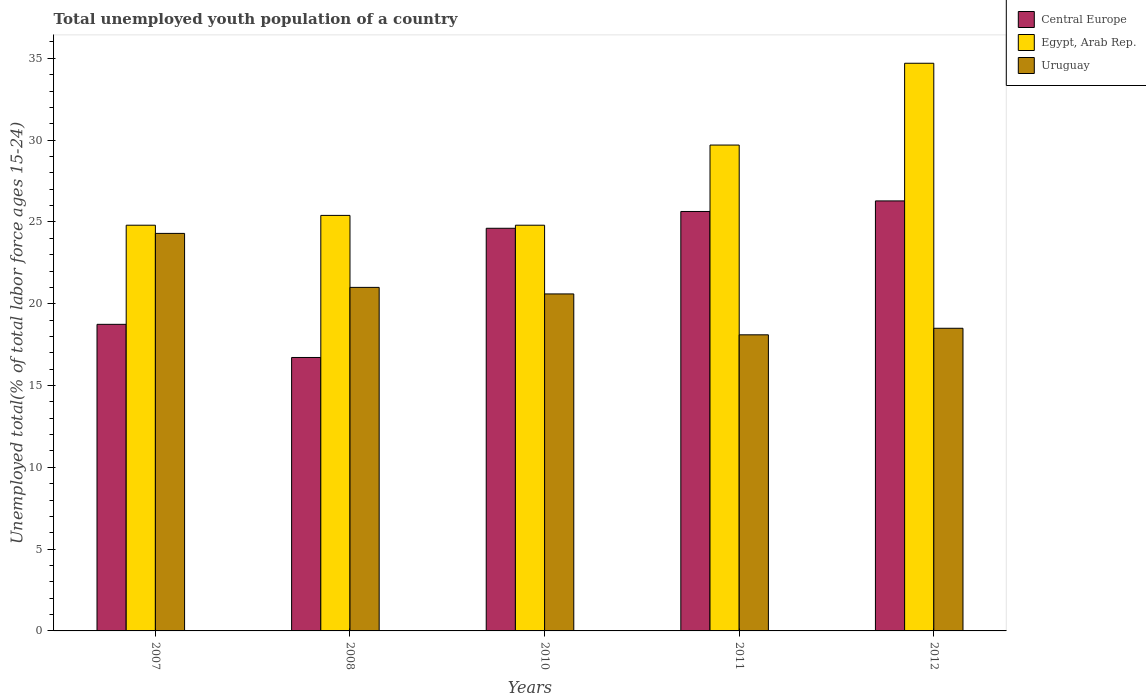How many bars are there on the 2nd tick from the left?
Make the answer very short. 3. What is the label of the 3rd group of bars from the left?
Your answer should be very brief. 2010. What is the percentage of total unemployed youth population of a country in Egypt, Arab Rep. in 2011?
Make the answer very short. 29.7. Across all years, what is the maximum percentage of total unemployed youth population of a country in Uruguay?
Provide a succinct answer. 24.3. Across all years, what is the minimum percentage of total unemployed youth population of a country in Egypt, Arab Rep.?
Your answer should be very brief. 24.8. In which year was the percentage of total unemployed youth population of a country in Egypt, Arab Rep. maximum?
Your answer should be very brief. 2012. In which year was the percentage of total unemployed youth population of a country in Central Europe minimum?
Your answer should be compact. 2008. What is the total percentage of total unemployed youth population of a country in Egypt, Arab Rep. in the graph?
Offer a very short reply. 139.4. What is the difference between the percentage of total unemployed youth population of a country in Uruguay in 2008 and that in 2012?
Make the answer very short. 2.5. What is the difference between the percentage of total unemployed youth population of a country in Egypt, Arab Rep. in 2007 and the percentage of total unemployed youth population of a country in Central Europe in 2010?
Offer a very short reply. 0.19. What is the average percentage of total unemployed youth population of a country in Central Europe per year?
Make the answer very short. 22.4. In the year 2011, what is the difference between the percentage of total unemployed youth population of a country in Egypt, Arab Rep. and percentage of total unemployed youth population of a country in Uruguay?
Make the answer very short. 11.6. What is the ratio of the percentage of total unemployed youth population of a country in Central Europe in 2007 to that in 2008?
Offer a terse response. 1.12. What is the difference between the highest and the second highest percentage of total unemployed youth population of a country in Egypt, Arab Rep.?
Provide a succinct answer. 5. What is the difference between the highest and the lowest percentage of total unemployed youth population of a country in Central Europe?
Provide a short and direct response. 9.57. In how many years, is the percentage of total unemployed youth population of a country in Central Europe greater than the average percentage of total unemployed youth population of a country in Central Europe taken over all years?
Offer a very short reply. 3. What does the 2nd bar from the left in 2011 represents?
Provide a short and direct response. Egypt, Arab Rep. What does the 1st bar from the right in 2008 represents?
Offer a very short reply. Uruguay. Is it the case that in every year, the sum of the percentage of total unemployed youth population of a country in Egypt, Arab Rep. and percentage of total unemployed youth population of a country in Uruguay is greater than the percentage of total unemployed youth population of a country in Central Europe?
Keep it short and to the point. Yes. How many years are there in the graph?
Your response must be concise. 5. What is the difference between two consecutive major ticks on the Y-axis?
Ensure brevity in your answer.  5. Are the values on the major ticks of Y-axis written in scientific E-notation?
Your response must be concise. No. Does the graph contain grids?
Offer a terse response. No. Where does the legend appear in the graph?
Provide a short and direct response. Top right. How are the legend labels stacked?
Ensure brevity in your answer.  Vertical. What is the title of the graph?
Your response must be concise. Total unemployed youth population of a country. Does "United Arab Emirates" appear as one of the legend labels in the graph?
Give a very brief answer. No. What is the label or title of the Y-axis?
Give a very brief answer. Unemployed total(% of total labor force ages 15-24). What is the Unemployed total(% of total labor force ages 15-24) in Central Europe in 2007?
Provide a succinct answer. 18.74. What is the Unemployed total(% of total labor force ages 15-24) of Egypt, Arab Rep. in 2007?
Your answer should be very brief. 24.8. What is the Unemployed total(% of total labor force ages 15-24) of Uruguay in 2007?
Give a very brief answer. 24.3. What is the Unemployed total(% of total labor force ages 15-24) of Central Europe in 2008?
Make the answer very short. 16.72. What is the Unemployed total(% of total labor force ages 15-24) of Egypt, Arab Rep. in 2008?
Provide a short and direct response. 25.4. What is the Unemployed total(% of total labor force ages 15-24) of Central Europe in 2010?
Your answer should be compact. 24.61. What is the Unemployed total(% of total labor force ages 15-24) in Egypt, Arab Rep. in 2010?
Make the answer very short. 24.8. What is the Unemployed total(% of total labor force ages 15-24) in Uruguay in 2010?
Your answer should be compact. 20.6. What is the Unemployed total(% of total labor force ages 15-24) in Central Europe in 2011?
Offer a terse response. 25.64. What is the Unemployed total(% of total labor force ages 15-24) in Egypt, Arab Rep. in 2011?
Your response must be concise. 29.7. What is the Unemployed total(% of total labor force ages 15-24) in Uruguay in 2011?
Your answer should be compact. 18.1. What is the Unemployed total(% of total labor force ages 15-24) of Central Europe in 2012?
Ensure brevity in your answer.  26.29. What is the Unemployed total(% of total labor force ages 15-24) of Egypt, Arab Rep. in 2012?
Make the answer very short. 34.7. What is the Unemployed total(% of total labor force ages 15-24) of Uruguay in 2012?
Provide a short and direct response. 18.5. Across all years, what is the maximum Unemployed total(% of total labor force ages 15-24) in Central Europe?
Provide a succinct answer. 26.29. Across all years, what is the maximum Unemployed total(% of total labor force ages 15-24) of Egypt, Arab Rep.?
Provide a short and direct response. 34.7. Across all years, what is the maximum Unemployed total(% of total labor force ages 15-24) of Uruguay?
Provide a short and direct response. 24.3. Across all years, what is the minimum Unemployed total(% of total labor force ages 15-24) in Central Europe?
Keep it short and to the point. 16.72. Across all years, what is the minimum Unemployed total(% of total labor force ages 15-24) in Egypt, Arab Rep.?
Your answer should be compact. 24.8. Across all years, what is the minimum Unemployed total(% of total labor force ages 15-24) of Uruguay?
Give a very brief answer. 18.1. What is the total Unemployed total(% of total labor force ages 15-24) in Central Europe in the graph?
Provide a succinct answer. 111.99. What is the total Unemployed total(% of total labor force ages 15-24) of Egypt, Arab Rep. in the graph?
Your answer should be very brief. 139.4. What is the total Unemployed total(% of total labor force ages 15-24) in Uruguay in the graph?
Ensure brevity in your answer.  102.5. What is the difference between the Unemployed total(% of total labor force ages 15-24) in Central Europe in 2007 and that in 2008?
Your answer should be very brief. 2.03. What is the difference between the Unemployed total(% of total labor force ages 15-24) in Central Europe in 2007 and that in 2010?
Give a very brief answer. -5.87. What is the difference between the Unemployed total(% of total labor force ages 15-24) in Egypt, Arab Rep. in 2007 and that in 2010?
Your answer should be very brief. 0. What is the difference between the Unemployed total(% of total labor force ages 15-24) of Central Europe in 2007 and that in 2011?
Keep it short and to the point. -6.9. What is the difference between the Unemployed total(% of total labor force ages 15-24) of Egypt, Arab Rep. in 2007 and that in 2011?
Your answer should be very brief. -4.9. What is the difference between the Unemployed total(% of total labor force ages 15-24) of Central Europe in 2007 and that in 2012?
Offer a very short reply. -7.54. What is the difference between the Unemployed total(% of total labor force ages 15-24) in Central Europe in 2008 and that in 2010?
Your response must be concise. -7.9. What is the difference between the Unemployed total(% of total labor force ages 15-24) in Uruguay in 2008 and that in 2010?
Provide a succinct answer. 0.4. What is the difference between the Unemployed total(% of total labor force ages 15-24) in Central Europe in 2008 and that in 2011?
Keep it short and to the point. -8.92. What is the difference between the Unemployed total(% of total labor force ages 15-24) in Egypt, Arab Rep. in 2008 and that in 2011?
Give a very brief answer. -4.3. What is the difference between the Unemployed total(% of total labor force ages 15-24) of Uruguay in 2008 and that in 2011?
Your answer should be very brief. 2.9. What is the difference between the Unemployed total(% of total labor force ages 15-24) of Central Europe in 2008 and that in 2012?
Your response must be concise. -9.57. What is the difference between the Unemployed total(% of total labor force ages 15-24) in Central Europe in 2010 and that in 2011?
Your response must be concise. -1.03. What is the difference between the Unemployed total(% of total labor force ages 15-24) of Central Europe in 2010 and that in 2012?
Your response must be concise. -1.67. What is the difference between the Unemployed total(% of total labor force ages 15-24) of Uruguay in 2010 and that in 2012?
Keep it short and to the point. 2.1. What is the difference between the Unemployed total(% of total labor force ages 15-24) of Central Europe in 2011 and that in 2012?
Your answer should be compact. -0.65. What is the difference between the Unemployed total(% of total labor force ages 15-24) of Central Europe in 2007 and the Unemployed total(% of total labor force ages 15-24) of Egypt, Arab Rep. in 2008?
Your answer should be compact. -6.66. What is the difference between the Unemployed total(% of total labor force ages 15-24) of Central Europe in 2007 and the Unemployed total(% of total labor force ages 15-24) of Uruguay in 2008?
Your response must be concise. -2.26. What is the difference between the Unemployed total(% of total labor force ages 15-24) of Central Europe in 2007 and the Unemployed total(% of total labor force ages 15-24) of Egypt, Arab Rep. in 2010?
Ensure brevity in your answer.  -6.06. What is the difference between the Unemployed total(% of total labor force ages 15-24) in Central Europe in 2007 and the Unemployed total(% of total labor force ages 15-24) in Uruguay in 2010?
Your answer should be very brief. -1.86. What is the difference between the Unemployed total(% of total labor force ages 15-24) in Egypt, Arab Rep. in 2007 and the Unemployed total(% of total labor force ages 15-24) in Uruguay in 2010?
Make the answer very short. 4.2. What is the difference between the Unemployed total(% of total labor force ages 15-24) in Central Europe in 2007 and the Unemployed total(% of total labor force ages 15-24) in Egypt, Arab Rep. in 2011?
Make the answer very short. -10.96. What is the difference between the Unemployed total(% of total labor force ages 15-24) in Central Europe in 2007 and the Unemployed total(% of total labor force ages 15-24) in Uruguay in 2011?
Provide a short and direct response. 0.64. What is the difference between the Unemployed total(% of total labor force ages 15-24) in Central Europe in 2007 and the Unemployed total(% of total labor force ages 15-24) in Egypt, Arab Rep. in 2012?
Give a very brief answer. -15.96. What is the difference between the Unemployed total(% of total labor force ages 15-24) in Central Europe in 2007 and the Unemployed total(% of total labor force ages 15-24) in Uruguay in 2012?
Offer a very short reply. 0.24. What is the difference between the Unemployed total(% of total labor force ages 15-24) in Egypt, Arab Rep. in 2007 and the Unemployed total(% of total labor force ages 15-24) in Uruguay in 2012?
Give a very brief answer. 6.3. What is the difference between the Unemployed total(% of total labor force ages 15-24) in Central Europe in 2008 and the Unemployed total(% of total labor force ages 15-24) in Egypt, Arab Rep. in 2010?
Provide a succinct answer. -8.08. What is the difference between the Unemployed total(% of total labor force ages 15-24) in Central Europe in 2008 and the Unemployed total(% of total labor force ages 15-24) in Uruguay in 2010?
Offer a terse response. -3.88. What is the difference between the Unemployed total(% of total labor force ages 15-24) in Egypt, Arab Rep. in 2008 and the Unemployed total(% of total labor force ages 15-24) in Uruguay in 2010?
Your response must be concise. 4.8. What is the difference between the Unemployed total(% of total labor force ages 15-24) of Central Europe in 2008 and the Unemployed total(% of total labor force ages 15-24) of Egypt, Arab Rep. in 2011?
Keep it short and to the point. -12.98. What is the difference between the Unemployed total(% of total labor force ages 15-24) of Central Europe in 2008 and the Unemployed total(% of total labor force ages 15-24) of Uruguay in 2011?
Make the answer very short. -1.38. What is the difference between the Unemployed total(% of total labor force ages 15-24) of Egypt, Arab Rep. in 2008 and the Unemployed total(% of total labor force ages 15-24) of Uruguay in 2011?
Provide a short and direct response. 7.3. What is the difference between the Unemployed total(% of total labor force ages 15-24) in Central Europe in 2008 and the Unemployed total(% of total labor force ages 15-24) in Egypt, Arab Rep. in 2012?
Keep it short and to the point. -17.98. What is the difference between the Unemployed total(% of total labor force ages 15-24) of Central Europe in 2008 and the Unemployed total(% of total labor force ages 15-24) of Uruguay in 2012?
Make the answer very short. -1.78. What is the difference between the Unemployed total(% of total labor force ages 15-24) in Egypt, Arab Rep. in 2008 and the Unemployed total(% of total labor force ages 15-24) in Uruguay in 2012?
Make the answer very short. 6.9. What is the difference between the Unemployed total(% of total labor force ages 15-24) of Central Europe in 2010 and the Unemployed total(% of total labor force ages 15-24) of Egypt, Arab Rep. in 2011?
Offer a terse response. -5.09. What is the difference between the Unemployed total(% of total labor force ages 15-24) of Central Europe in 2010 and the Unemployed total(% of total labor force ages 15-24) of Uruguay in 2011?
Offer a very short reply. 6.51. What is the difference between the Unemployed total(% of total labor force ages 15-24) in Egypt, Arab Rep. in 2010 and the Unemployed total(% of total labor force ages 15-24) in Uruguay in 2011?
Provide a succinct answer. 6.7. What is the difference between the Unemployed total(% of total labor force ages 15-24) of Central Europe in 2010 and the Unemployed total(% of total labor force ages 15-24) of Egypt, Arab Rep. in 2012?
Keep it short and to the point. -10.09. What is the difference between the Unemployed total(% of total labor force ages 15-24) in Central Europe in 2010 and the Unemployed total(% of total labor force ages 15-24) in Uruguay in 2012?
Offer a very short reply. 6.11. What is the difference between the Unemployed total(% of total labor force ages 15-24) of Egypt, Arab Rep. in 2010 and the Unemployed total(% of total labor force ages 15-24) of Uruguay in 2012?
Make the answer very short. 6.3. What is the difference between the Unemployed total(% of total labor force ages 15-24) in Central Europe in 2011 and the Unemployed total(% of total labor force ages 15-24) in Egypt, Arab Rep. in 2012?
Keep it short and to the point. -9.06. What is the difference between the Unemployed total(% of total labor force ages 15-24) in Central Europe in 2011 and the Unemployed total(% of total labor force ages 15-24) in Uruguay in 2012?
Make the answer very short. 7.14. What is the difference between the Unemployed total(% of total labor force ages 15-24) of Egypt, Arab Rep. in 2011 and the Unemployed total(% of total labor force ages 15-24) of Uruguay in 2012?
Offer a terse response. 11.2. What is the average Unemployed total(% of total labor force ages 15-24) of Central Europe per year?
Ensure brevity in your answer.  22.4. What is the average Unemployed total(% of total labor force ages 15-24) of Egypt, Arab Rep. per year?
Keep it short and to the point. 27.88. In the year 2007, what is the difference between the Unemployed total(% of total labor force ages 15-24) in Central Europe and Unemployed total(% of total labor force ages 15-24) in Egypt, Arab Rep.?
Make the answer very short. -6.06. In the year 2007, what is the difference between the Unemployed total(% of total labor force ages 15-24) in Central Europe and Unemployed total(% of total labor force ages 15-24) in Uruguay?
Your answer should be compact. -5.56. In the year 2007, what is the difference between the Unemployed total(% of total labor force ages 15-24) in Egypt, Arab Rep. and Unemployed total(% of total labor force ages 15-24) in Uruguay?
Provide a short and direct response. 0.5. In the year 2008, what is the difference between the Unemployed total(% of total labor force ages 15-24) of Central Europe and Unemployed total(% of total labor force ages 15-24) of Egypt, Arab Rep.?
Provide a succinct answer. -8.68. In the year 2008, what is the difference between the Unemployed total(% of total labor force ages 15-24) in Central Europe and Unemployed total(% of total labor force ages 15-24) in Uruguay?
Your answer should be very brief. -4.28. In the year 2008, what is the difference between the Unemployed total(% of total labor force ages 15-24) in Egypt, Arab Rep. and Unemployed total(% of total labor force ages 15-24) in Uruguay?
Provide a succinct answer. 4.4. In the year 2010, what is the difference between the Unemployed total(% of total labor force ages 15-24) in Central Europe and Unemployed total(% of total labor force ages 15-24) in Egypt, Arab Rep.?
Offer a terse response. -0.19. In the year 2010, what is the difference between the Unemployed total(% of total labor force ages 15-24) in Central Europe and Unemployed total(% of total labor force ages 15-24) in Uruguay?
Ensure brevity in your answer.  4.01. In the year 2011, what is the difference between the Unemployed total(% of total labor force ages 15-24) of Central Europe and Unemployed total(% of total labor force ages 15-24) of Egypt, Arab Rep.?
Make the answer very short. -4.06. In the year 2011, what is the difference between the Unemployed total(% of total labor force ages 15-24) of Central Europe and Unemployed total(% of total labor force ages 15-24) of Uruguay?
Give a very brief answer. 7.54. In the year 2012, what is the difference between the Unemployed total(% of total labor force ages 15-24) in Central Europe and Unemployed total(% of total labor force ages 15-24) in Egypt, Arab Rep.?
Keep it short and to the point. -8.41. In the year 2012, what is the difference between the Unemployed total(% of total labor force ages 15-24) in Central Europe and Unemployed total(% of total labor force ages 15-24) in Uruguay?
Your answer should be very brief. 7.79. What is the ratio of the Unemployed total(% of total labor force ages 15-24) in Central Europe in 2007 to that in 2008?
Offer a terse response. 1.12. What is the ratio of the Unemployed total(% of total labor force ages 15-24) in Egypt, Arab Rep. in 2007 to that in 2008?
Keep it short and to the point. 0.98. What is the ratio of the Unemployed total(% of total labor force ages 15-24) in Uruguay in 2007 to that in 2008?
Make the answer very short. 1.16. What is the ratio of the Unemployed total(% of total labor force ages 15-24) of Central Europe in 2007 to that in 2010?
Your answer should be compact. 0.76. What is the ratio of the Unemployed total(% of total labor force ages 15-24) in Egypt, Arab Rep. in 2007 to that in 2010?
Your response must be concise. 1. What is the ratio of the Unemployed total(% of total labor force ages 15-24) in Uruguay in 2007 to that in 2010?
Make the answer very short. 1.18. What is the ratio of the Unemployed total(% of total labor force ages 15-24) of Central Europe in 2007 to that in 2011?
Provide a short and direct response. 0.73. What is the ratio of the Unemployed total(% of total labor force ages 15-24) of Egypt, Arab Rep. in 2007 to that in 2011?
Ensure brevity in your answer.  0.83. What is the ratio of the Unemployed total(% of total labor force ages 15-24) of Uruguay in 2007 to that in 2011?
Your answer should be very brief. 1.34. What is the ratio of the Unemployed total(% of total labor force ages 15-24) in Central Europe in 2007 to that in 2012?
Your response must be concise. 0.71. What is the ratio of the Unemployed total(% of total labor force ages 15-24) of Egypt, Arab Rep. in 2007 to that in 2012?
Ensure brevity in your answer.  0.71. What is the ratio of the Unemployed total(% of total labor force ages 15-24) in Uruguay in 2007 to that in 2012?
Your response must be concise. 1.31. What is the ratio of the Unemployed total(% of total labor force ages 15-24) of Central Europe in 2008 to that in 2010?
Offer a very short reply. 0.68. What is the ratio of the Unemployed total(% of total labor force ages 15-24) in Egypt, Arab Rep. in 2008 to that in 2010?
Your answer should be very brief. 1.02. What is the ratio of the Unemployed total(% of total labor force ages 15-24) in Uruguay in 2008 to that in 2010?
Offer a terse response. 1.02. What is the ratio of the Unemployed total(% of total labor force ages 15-24) of Central Europe in 2008 to that in 2011?
Your answer should be very brief. 0.65. What is the ratio of the Unemployed total(% of total labor force ages 15-24) in Egypt, Arab Rep. in 2008 to that in 2011?
Offer a very short reply. 0.86. What is the ratio of the Unemployed total(% of total labor force ages 15-24) of Uruguay in 2008 to that in 2011?
Your answer should be very brief. 1.16. What is the ratio of the Unemployed total(% of total labor force ages 15-24) of Central Europe in 2008 to that in 2012?
Provide a succinct answer. 0.64. What is the ratio of the Unemployed total(% of total labor force ages 15-24) in Egypt, Arab Rep. in 2008 to that in 2012?
Offer a terse response. 0.73. What is the ratio of the Unemployed total(% of total labor force ages 15-24) of Uruguay in 2008 to that in 2012?
Your response must be concise. 1.14. What is the ratio of the Unemployed total(% of total labor force ages 15-24) in Egypt, Arab Rep. in 2010 to that in 2011?
Offer a terse response. 0.83. What is the ratio of the Unemployed total(% of total labor force ages 15-24) of Uruguay in 2010 to that in 2011?
Ensure brevity in your answer.  1.14. What is the ratio of the Unemployed total(% of total labor force ages 15-24) in Central Europe in 2010 to that in 2012?
Give a very brief answer. 0.94. What is the ratio of the Unemployed total(% of total labor force ages 15-24) of Egypt, Arab Rep. in 2010 to that in 2012?
Your answer should be compact. 0.71. What is the ratio of the Unemployed total(% of total labor force ages 15-24) in Uruguay in 2010 to that in 2012?
Your answer should be compact. 1.11. What is the ratio of the Unemployed total(% of total labor force ages 15-24) of Central Europe in 2011 to that in 2012?
Your response must be concise. 0.98. What is the ratio of the Unemployed total(% of total labor force ages 15-24) of Egypt, Arab Rep. in 2011 to that in 2012?
Make the answer very short. 0.86. What is the ratio of the Unemployed total(% of total labor force ages 15-24) of Uruguay in 2011 to that in 2012?
Give a very brief answer. 0.98. What is the difference between the highest and the second highest Unemployed total(% of total labor force ages 15-24) of Central Europe?
Ensure brevity in your answer.  0.65. What is the difference between the highest and the second highest Unemployed total(% of total labor force ages 15-24) in Egypt, Arab Rep.?
Your response must be concise. 5. What is the difference between the highest and the lowest Unemployed total(% of total labor force ages 15-24) in Central Europe?
Offer a very short reply. 9.57. 